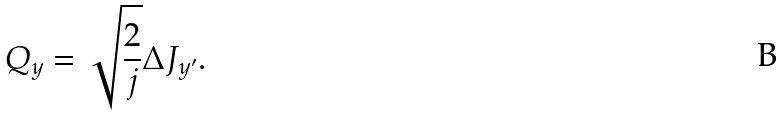Convert formula to latex. <formula><loc_0><loc_0><loc_500><loc_500>Q _ { y } = \sqrt { \frac { 2 } { j } } \Delta { J } _ { y ^ { \prime } } .</formula> 